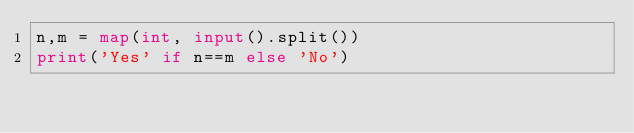<code> <loc_0><loc_0><loc_500><loc_500><_Python_>n,m = map(int, input().split())
print('Yes' if n==m else 'No')</code> 